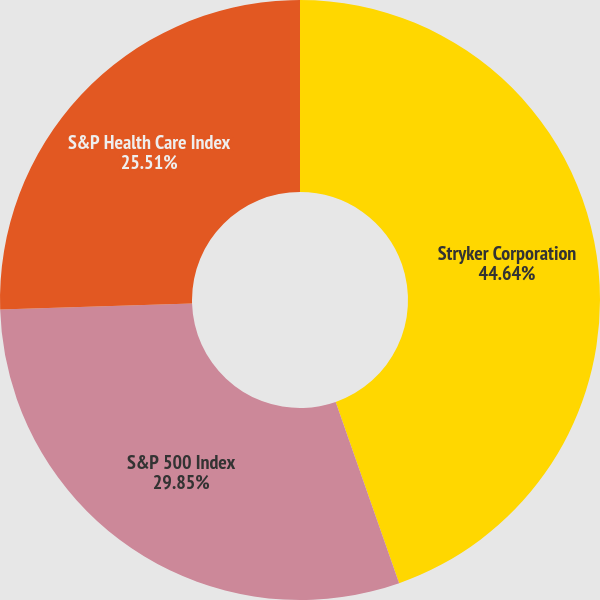<chart> <loc_0><loc_0><loc_500><loc_500><pie_chart><fcel>Stryker Corporation<fcel>S&P 500 Index<fcel>S&P Health Care Index<nl><fcel>44.64%<fcel>29.85%<fcel>25.51%<nl></chart> 